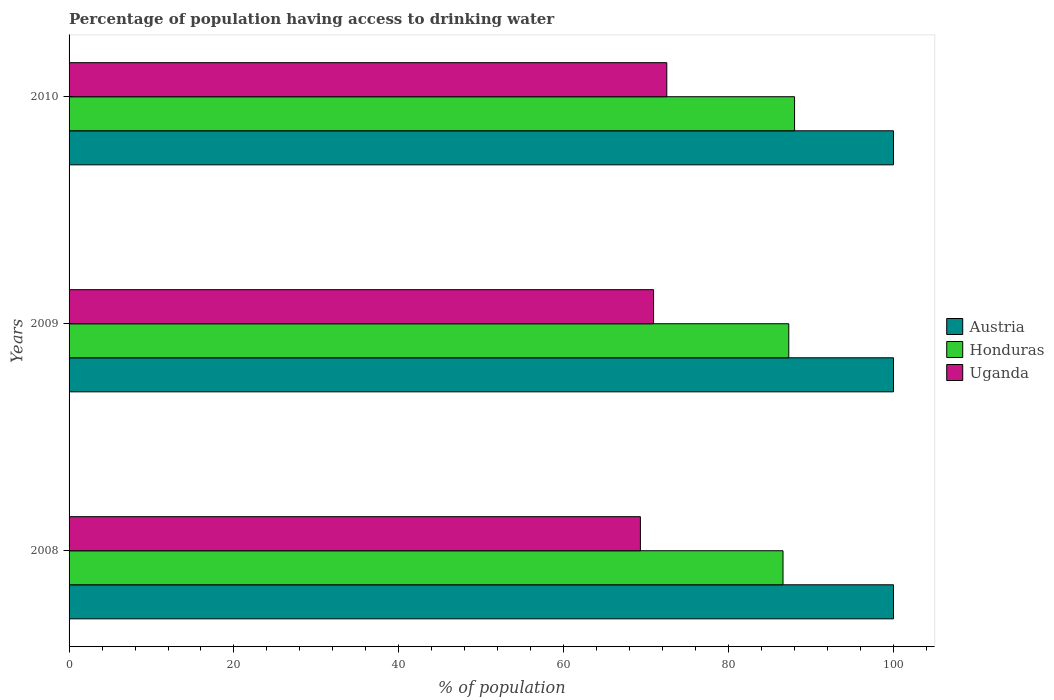How many different coloured bars are there?
Offer a very short reply. 3. In how many cases, is the number of bars for a given year not equal to the number of legend labels?
Ensure brevity in your answer.  0. What is the percentage of population having access to drinking water in Uganda in 2010?
Your response must be concise. 72.5. Across all years, what is the maximum percentage of population having access to drinking water in Austria?
Ensure brevity in your answer.  100. Across all years, what is the minimum percentage of population having access to drinking water in Austria?
Provide a succinct answer. 100. In which year was the percentage of population having access to drinking water in Honduras maximum?
Offer a very short reply. 2010. What is the total percentage of population having access to drinking water in Austria in the graph?
Your answer should be very brief. 300. What is the difference between the percentage of population having access to drinking water in Austria in 2010 and the percentage of population having access to drinking water in Honduras in 2008?
Ensure brevity in your answer.  13.4. What is the average percentage of population having access to drinking water in Austria per year?
Keep it short and to the point. 100. In the year 2010, what is the difference between the percentage of population having access to drinking water in Honduras and percentage of population having access to drinking water in Austria?
Your response must be concise. -12. What is the ratio of the percentage of population having access to drinking water in Austria in 2009 to that in 2010?
Offer a very short reply. 1. Is the percentage of population having access to drinking water in Austria in 2008 less than that in 2009?
Make the answer very short. No. Is the difference between the percentage of population having access to drinking water in Honduras in 2008 and 2009 greater than the difference between the percentage of population having access to drinking water in Austria in 2008 and 2009?
Your answer should be compact. No. What is the difference between the highest and the second highest percentage of population having access to drinking water in Uganda?
Ensure brevity in your answer.  1.6. What is the difference between the highest and the lowest percentage of population having access to drinking water in Honduras?
Your answer should be very brief. 1.4. What does the 1st bar from the top in 2008 represents?
Ensure brevity in your answer.  Uganda. What does the 2nd bar from the bottom in 2010 represents?
Offer a terse response. Honduras. Is it the case that in every year, the sum of the percentage of population having access to drinking water in Honduras and percentage of population having access to drinking water in Austria is greater than the percentage of population having access to drinking water in Uganda?
Your answer should be compact. Yes. How many bars are there?
Offer a very short reply. 9. How many years are there in the graph?
Offer a terse response. 3. What is the difference between two consecutive major ticks on the X-axis?
Offer a terse response. 20. Are the values on the major ticks of X-axis written in scientific E-notation?
Offer a very short reply. No. Where does the legend appear in the graph?
Give a very brief answer. Center right. How are the legend labels stacked?
Give a very brief answer. Vertical. What is the title of the graph?
Offer a very short reply. Percentage of population having access to drinking water. Does "Senegal" appear as one of the legend labels in the graph?
Provide a succinct answer. No. What is the label or title of the X-axis?
Ensure brevity in your answer.  % of population. What is the % of population of Austria in 2008?
Your response must be concise. 100. What is the % of population of Honduras in 2008?
Your answer should be compact. 86.6. What is the % of population of Uganda in 2008?
Your answer should be very brief. 69.3. What is the % of population in Austria in 2009?
Ensure brevity in your answer.  100. What is the % of population in Honduras in 2009?
Your response must be concise. 87.3. What is the % of population in Uganda in 2009?
Your answer should be very brief. 70.9. What is the % of population in Austria in 2010?
Give a very brief answer. 100. What is the % of population of Honduras in 2010?
Offer a very short reply. 88. What is the % of population of Uganda in 2010?
Give a very brief answer. 72.5. Across all years, what is the maximum % of population in Austria?
Provide a succinct answer. 100. Across all years, what is the maximum % of population of Honduras?
Offer a terse response. 88. Across all years, what is the maximum % of population of Uganda?
Ensure brevity in your answer.  72.5. Across all years, what is the minimum % of population of Austria?
Your answer should be compact. 100. Across all years, what is the minimum % of population of Honduras?
Your answer should be compact. 86.6. Across all years, what is the minimum % of population of Uganda?
Provide a succinct answer. 69.3. What is the total % of population in Austria in the graph?
Provide a short and direct response. 300. What is the total % of population of Honduras in the graph?
Your answer should be very brief. 261.9. What is the total % of population in Uganda in the graph?
Provide a succinct answer. 212.7. What is the difference between the % of population in Austria in 2008 and that in 2009?
Provide a short and direct response. 0. What is the difference between the % of population of Honduras in 2008 and that in 2010?
Offer a terse response. -1.4. What is the difference between the % of population in Uganda in 2008 and that in 2010?
Your answer should be compact. -3.2. What is the difference between the % of population in Honduras in 2009 and that in 2010?
Offer a very short reply. -0.7. What is the difference between the % of population in Uganda in 2009 and that in 2010?
Give a very brief answer. -1.6. What is the difference between the % of population of Austria in 2008 and the % of population of Uganda in 2009?
Keep it short and to the point. 29.1. What is the difference between the % of population in Austria in 2008 and the % of population in Uganda in 2010?
Give a very brief answer. 27.5. What is the difference between the % of population of Honduras in 2008 and the % of population of Uganda in 2010?
Provide a short and direct response. 14.1. What is the difference between the % of population in Honduras in 2009 and the % of population in Uganda in 2010?
Keep it short and to the point. 14.8. What is the average % of population of Honduras per year?
Your response must be concise. 87.3. What is the average % of population in Uganda per year?
Your response must be concise. 70.9. In the year 2008, what is the difference between the % of population in Austria and % of population in Honduras?
Your answer should be compact. 13.4. In the year 2008, what is the difference between the % of population of Austria and % of population of Uganda?
Offer a very short reply. 30.7. In the year 2008, what is the difference between the % of population in Honduras and % of population in Uganda?
Keep it short and to the point. 17.3. In the year 2009, what is the difference between the % of population of Austria and % of population of Uganda?
Your answer should be compact. 29.1. In the year 2010, what is the difference between the % of population of Austria and % of population of Honduras?
Keep it short and to the point. 12. In the year 2010, what is the difference between the % of population in Austria and % of population in Uganda?
Your answer should be compact. 27.5. In the year 2010, what is the difference between the % of population in Honduras and % of population in Uganda?
Ensure brevity in your answer.  15.5. What is the ratio of the % of population in Honduras in 2008 to that in 2009?
Give a very brief answer. 0.99. What is the ratio of the % of population of Uganda in 2008 to that in 2009?
Keep it short and to the point. 0.98. What is the ratio of the % of population in Honduras in 2008 to that in 2010?
Your answer should be compact. 0.98. What is the ratio of the % of population of Uganda in 2008 to that in 2010?
Offer a terse response. 0.96. What is the ratio of the % of population in Austria in 2009 to that in 2010?
Give a very brief answer. 1. What is the ratio of the % of population in Uganda in 2009 to that in 2010?
Your answer should be compact. 0.98. What is the difference between the highest and the second highest % of population of Austria?
Make the answer very short. 0. What is the difference between the highest and the second highest % of population of Honduras?
Provide a short and direct response. 0.7. What is the difference between the highest and the second highest % of population in Uganda?
Your answer should be compact. 1.6. 